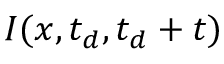<formula> <loc_0><loc_0><loc_500><loc_500>I ( x , t _ { d } , t _ { d } + t )</formula> 